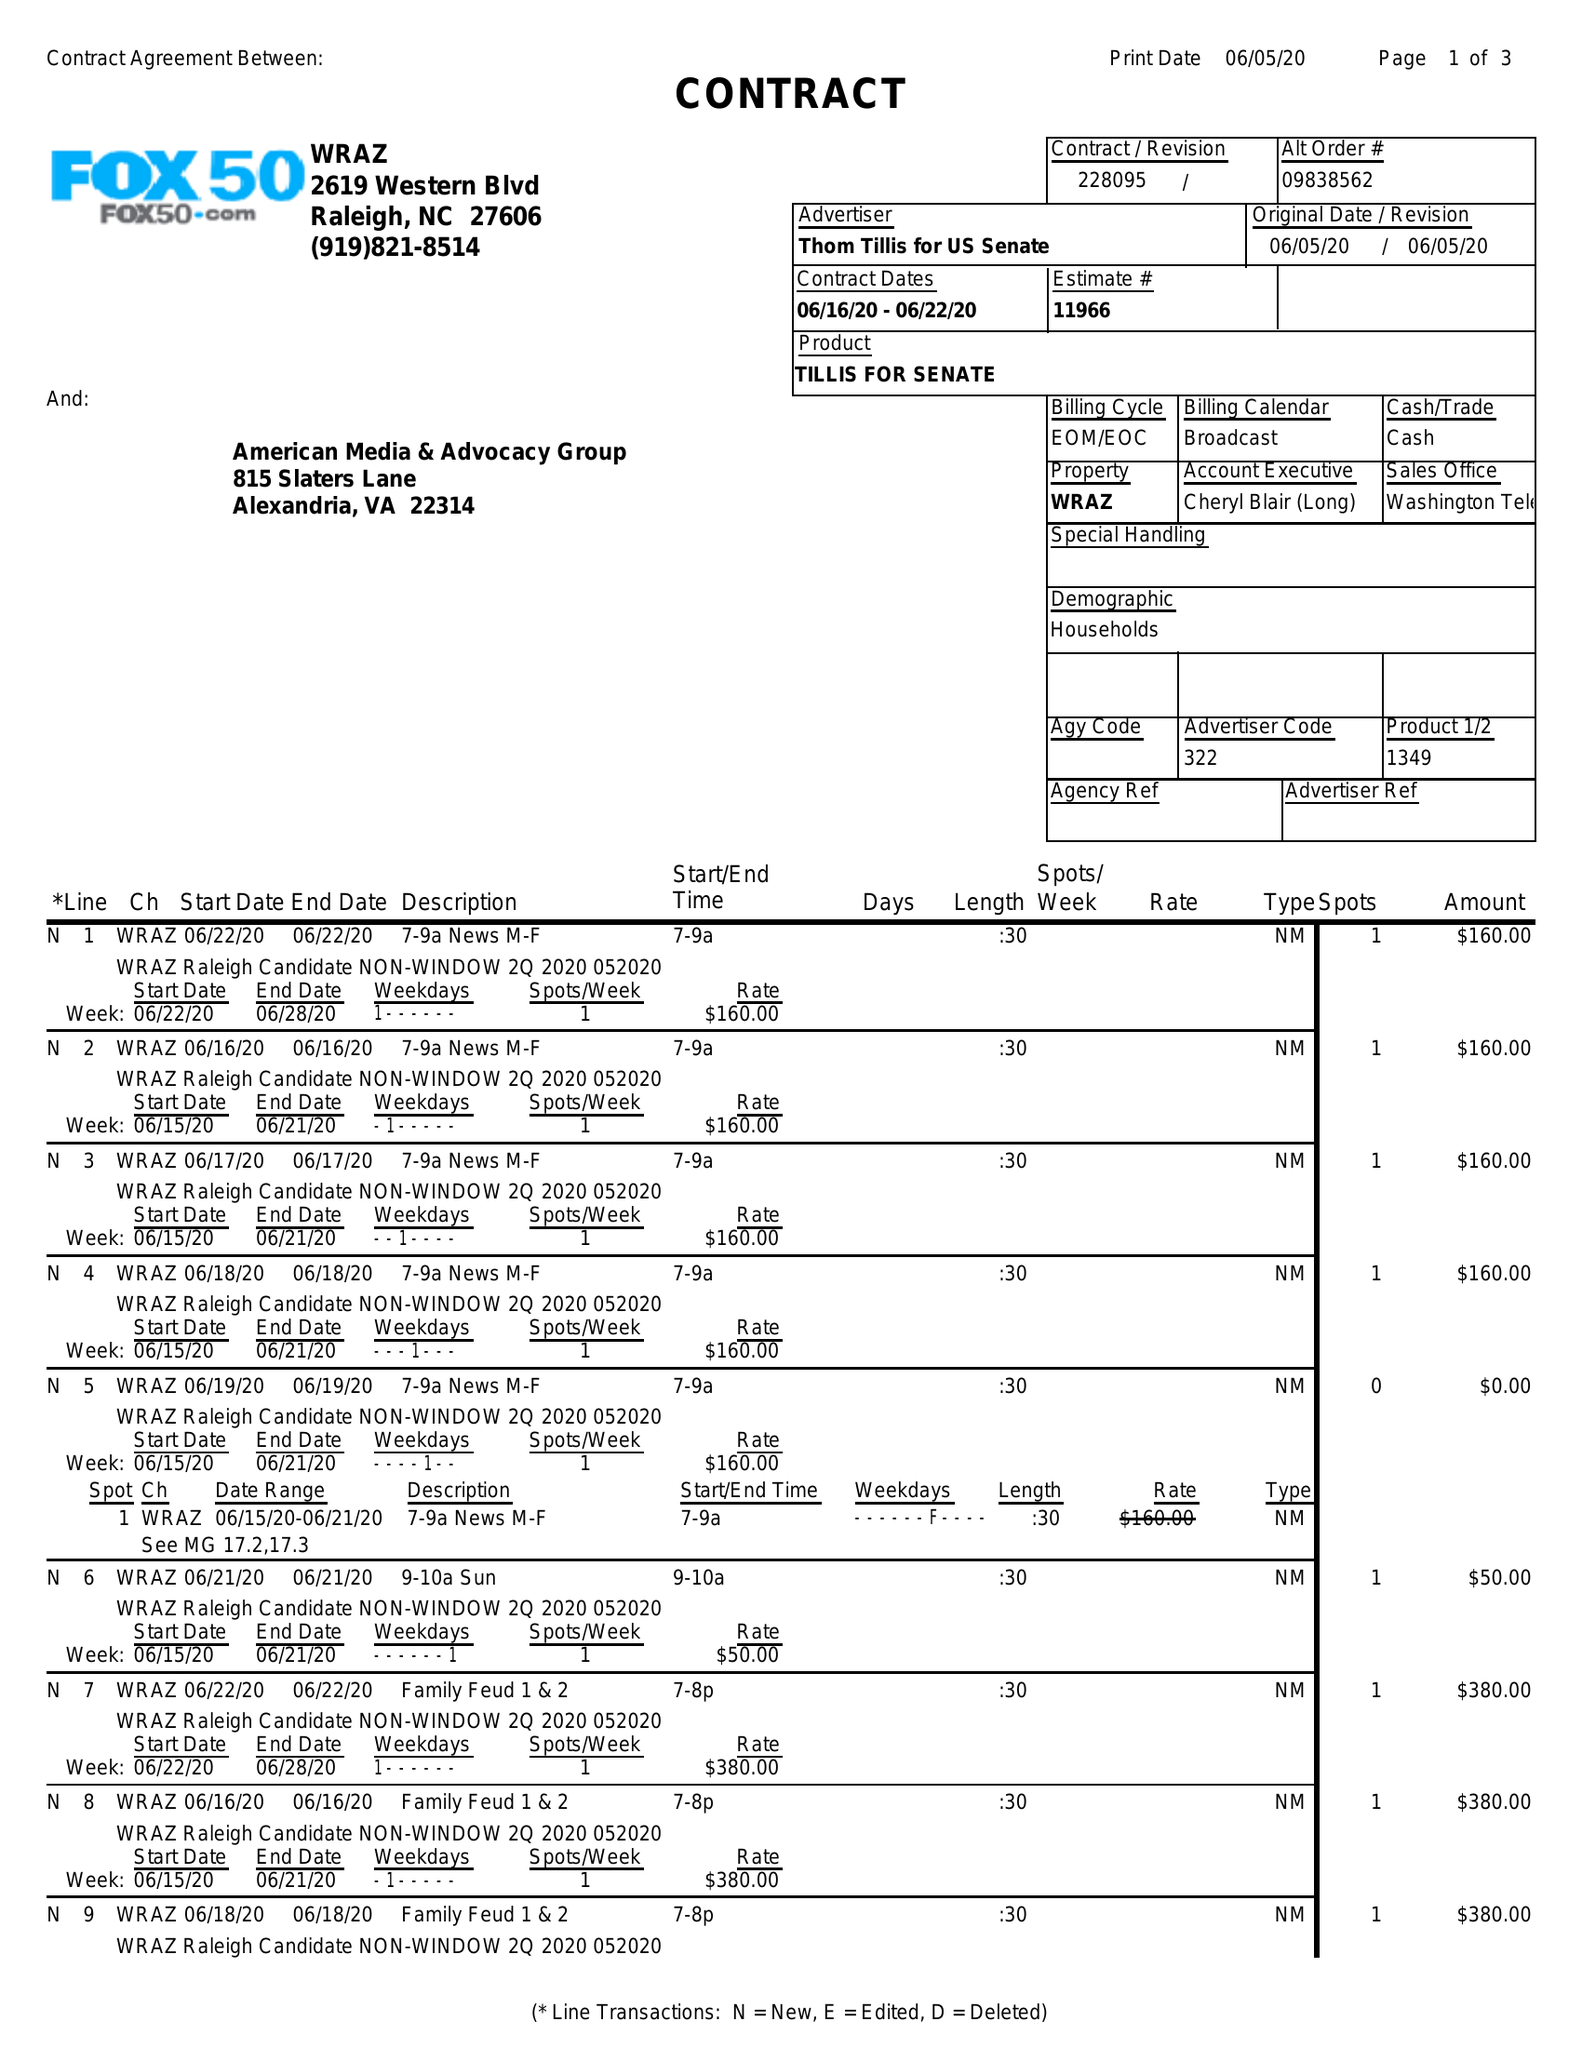What is the value for the contract_num?
Answer the question using a single word or phrase. 228095 